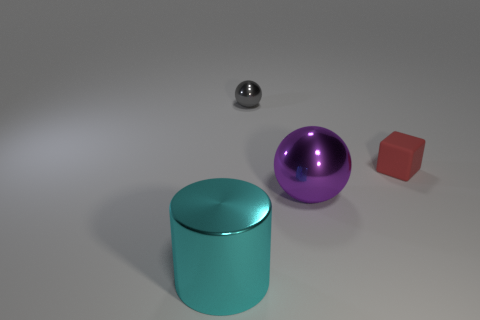Subtract all purple balls. How many balls are left? 1 Subtract 1 spheres. How many spheres are left? 1 Add 3 tiny cyan rubber things. How many objects exist? 7 Subtract all cylinders. How many objects are left? 3 Subtract all yellow spheres. Subtract all yellow cubes. How many spheres are left? 2 Subtract all small red matte objects. Subtract all big spheres. How many objects are left? 2 Add 1 tiny gray metallic things. How many tiny gray metallic things are left? 2 Add 4 metal spheres. How many metal spheres exist? 6 Subtract 0 purple cylinders. How many objects are left? 4 